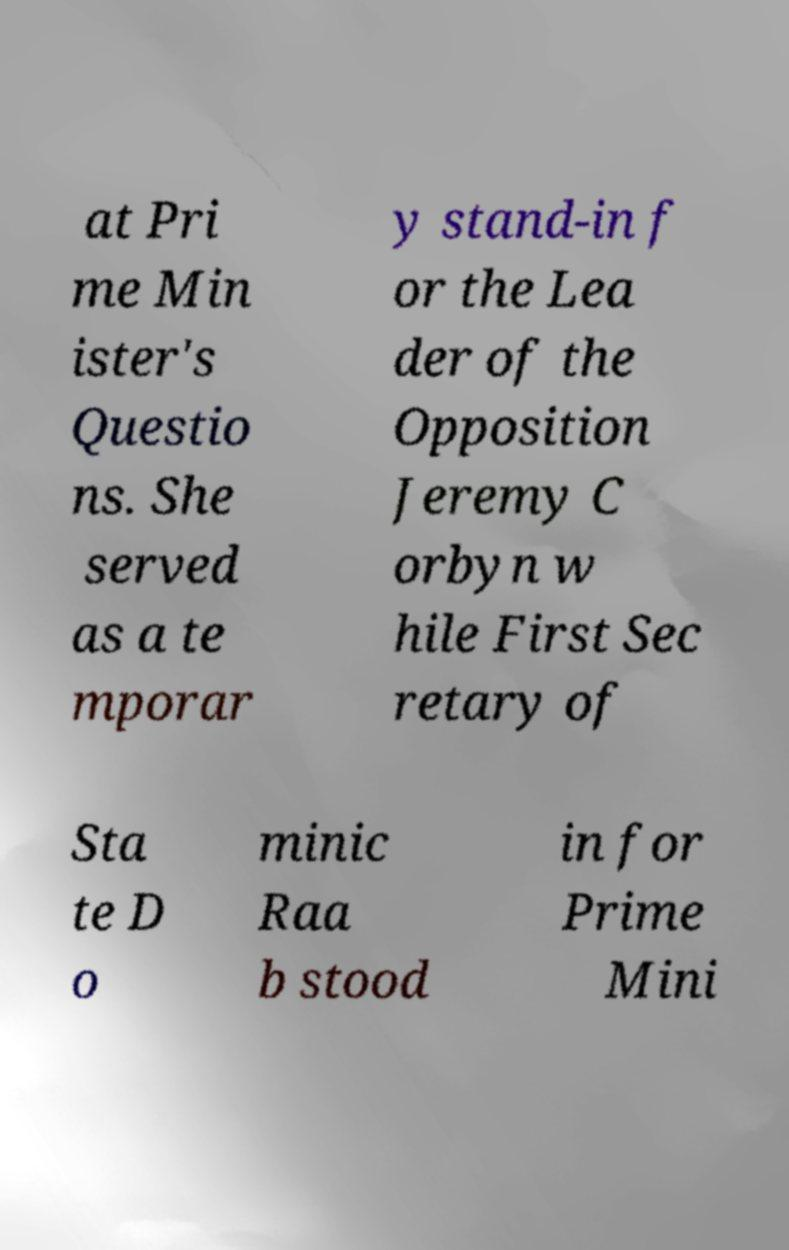What messages or text are displayed in this image? I need them in a readable, typed format. at Pri me Min ister's Questio ns. She served as a te mporar y stand-in f or the Lea der of the Opposition Jeremy C orbyn w hile First Sec retary of Sta te D o minic Raa b stood in for Prime Mini 